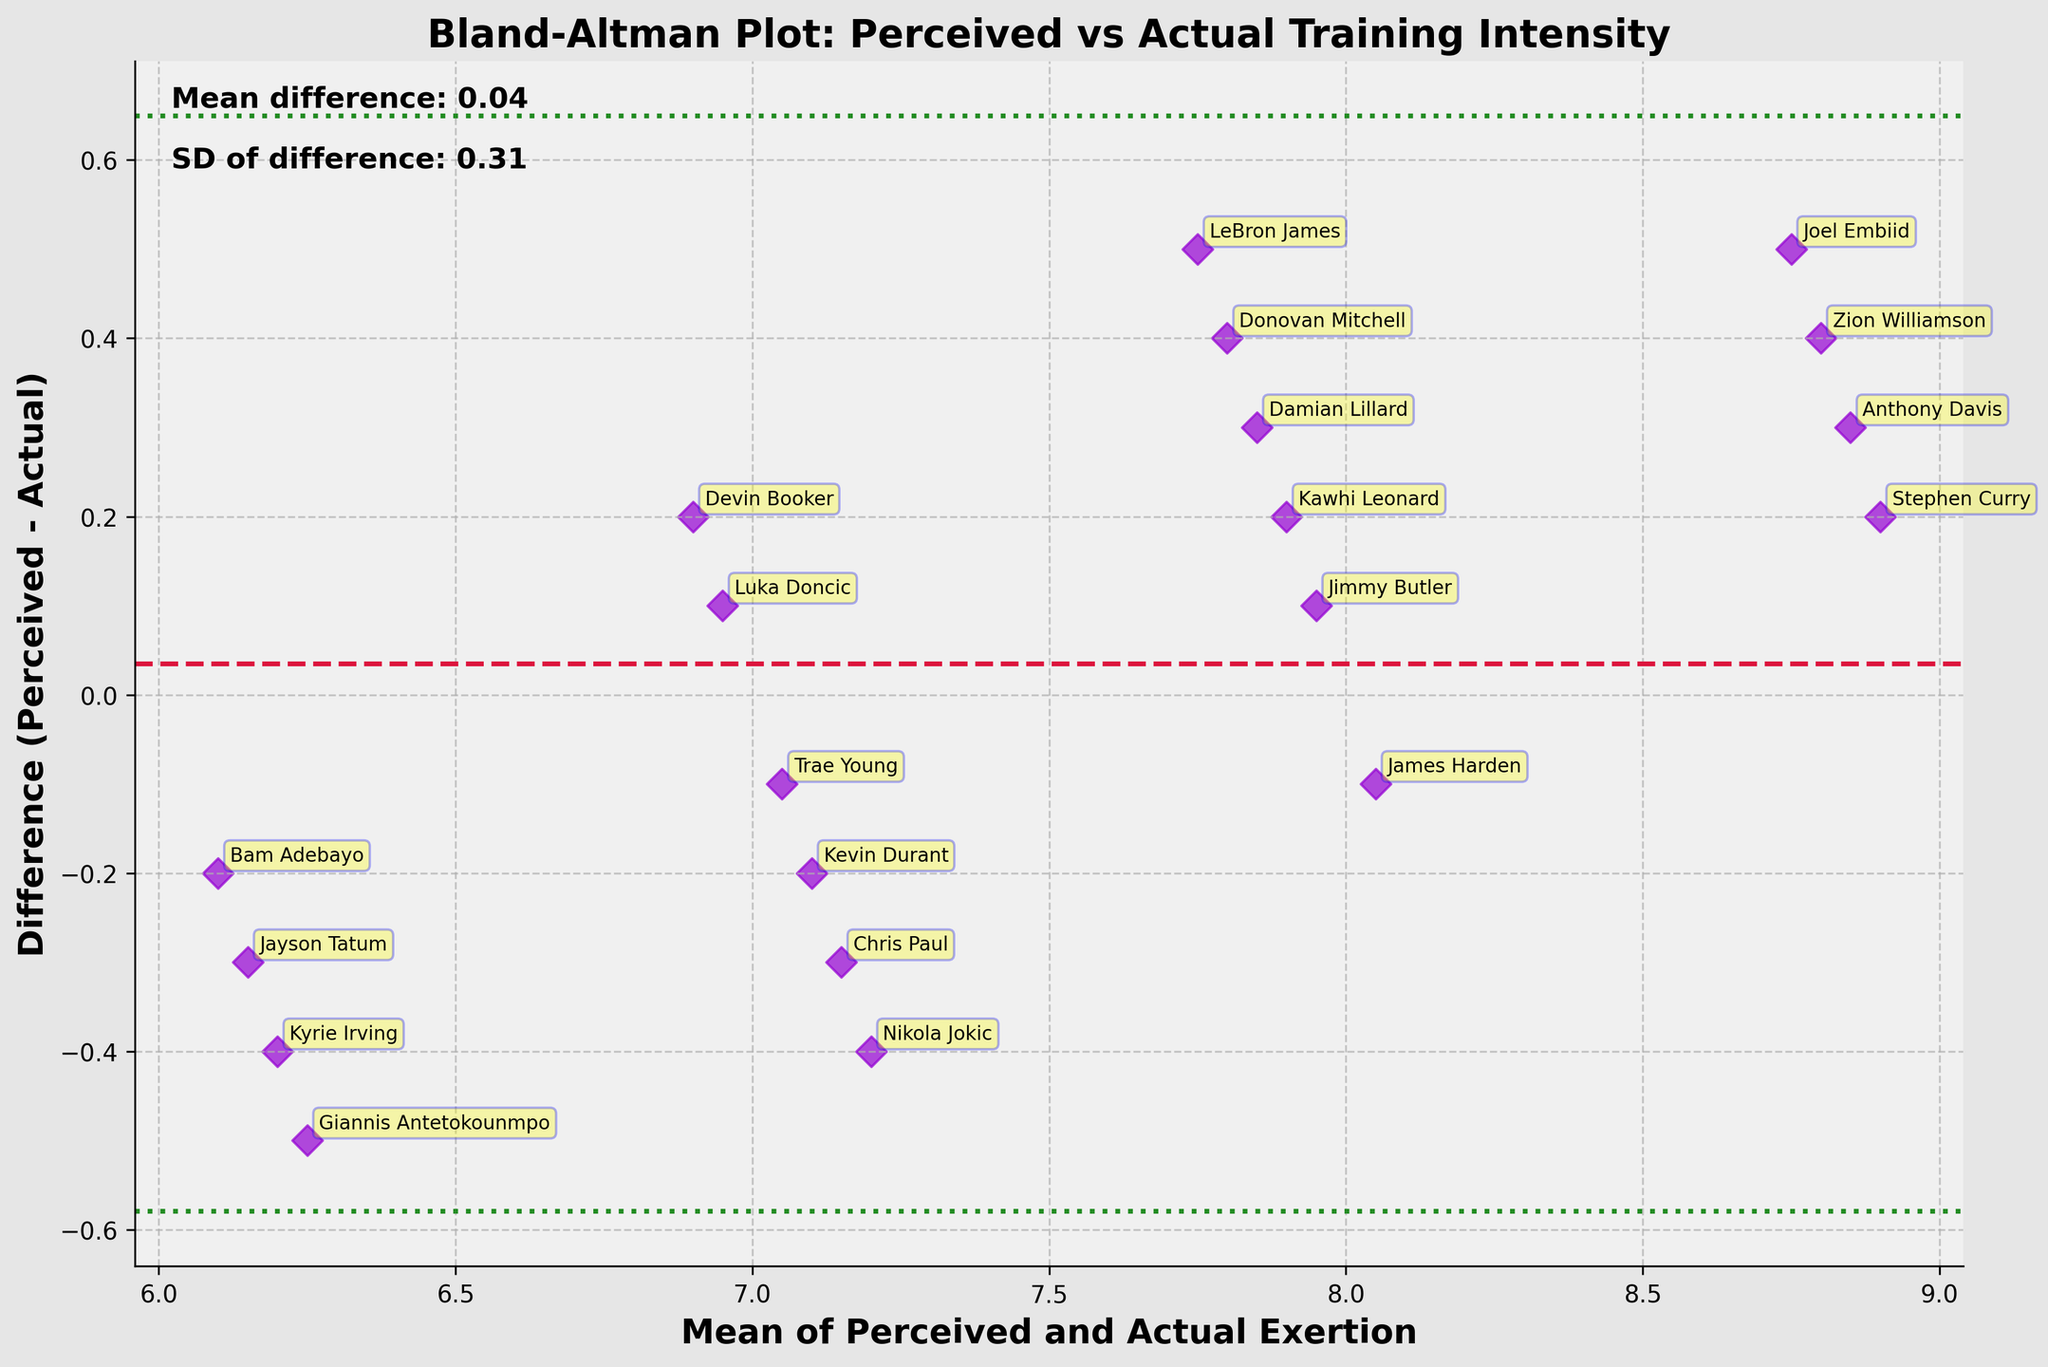How many data points represent perceived vs. actual exertion levels? By counting all the players in the figure representing perceived vs. actual exertion levels, we find 20 data points in total.
Answer: 20 What does the mean difference line indicate? The mean difference line, marked as a dashed crimson line, indicates the average difference between the perceived exertion levels and the actual training intensities across all the players.
Answer: Average difference Which player has the largest positive difference between perceived and actual exertion? By observing the scatter plot, we find that Stephen Curry has the largest positive difference, where his perceived exertion is 9 while the actual intensity is 8.8.
Answer: Stephen Curry What are the 95% limits of agreement for the data? The Bland-Altman plot shows two green dotted lines representing the 95% limits of agreement. These limits are calculated as the mean difference plus or minus 1.96 times the standard deviation of the differences.
Answer: Mean difference ± 1.96*SD How is the "mean of perceived and actual exertion" calculated for each player? The "mean of perceived and actual exertion" for each player is calculated by averaging the perceived exertion and actual intensity values.
Answer: Average of perceived and actual Which player is closest to having no difference between perceived and actual exertion levels? By examining the plot, Kevin Durant is closest to the zero difference line, meaning his perceived exertion is very close to his actual intensity.
Answer: Kevin Durant What color represents the scatter points in the plot? In the plot, the scatter points representing each player are dark violet.
Answer: Dark violet What is the range of the mean of perceived and actual exertion values across all data points? Observing the x-axis, we see the range of the mean values spans approximately from 6 to 9.
Answer: 6 to 9 How does the actual exertion compare to perceived exertion on average? The mean difference (crimson line) shows that, on average, perceived exertion is slightly higher than the actual exertion.
Answer: Perceived > Actual (on average) How many players' perceived exertion is higher than their actual intensity? By examining the plot, if a point is above the zero difference line, it indicates a higher perceived exertion than actual intensity. There are 13 such players.
Answer: 13 